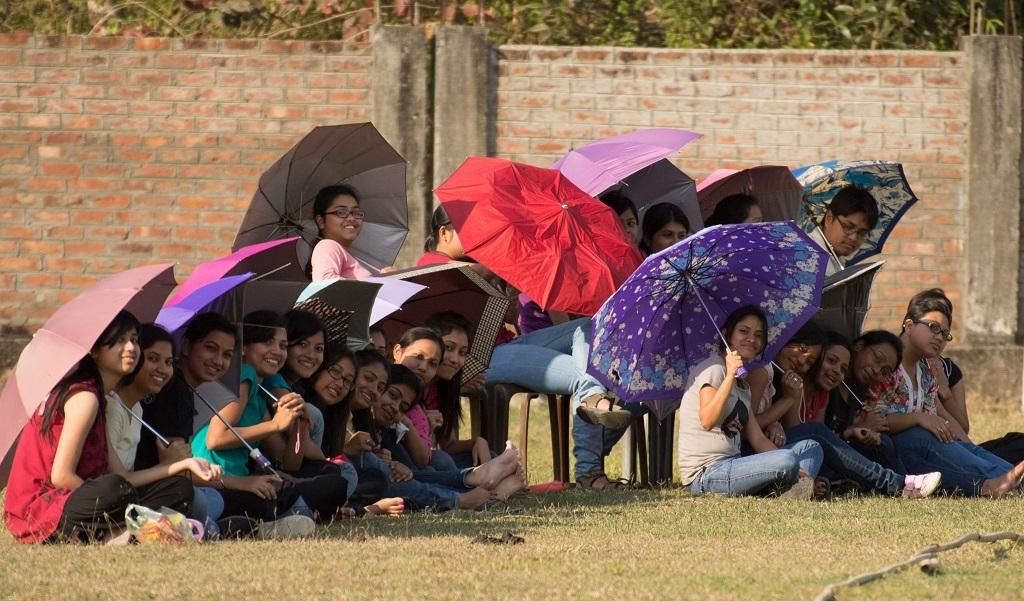What are the people in the image doing? The people in the image are sitting on the ground and on chairs. What are the people holding in the image? All people are holding umbrellas. What can be seen in the background of the image? There are walls and trees in the background. Are there any deer visible in the image? No, there are no deer present in the image. What type of balloon is being used to adjust the umbrellas in the image? There is no balloon present in the image, and the umbrellas are not being adjusted. 